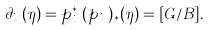Convert formula to latex. <formula><loc_0><loc_0><loc_500><loc_500>\partial _ { i _ { k } } ( \eta ) = p _ { i _ { k } } ^ { * } ( p _ { i _ { k } } ) _ { * } ( \eta ) = [ G / B ] \/ .</formula> 